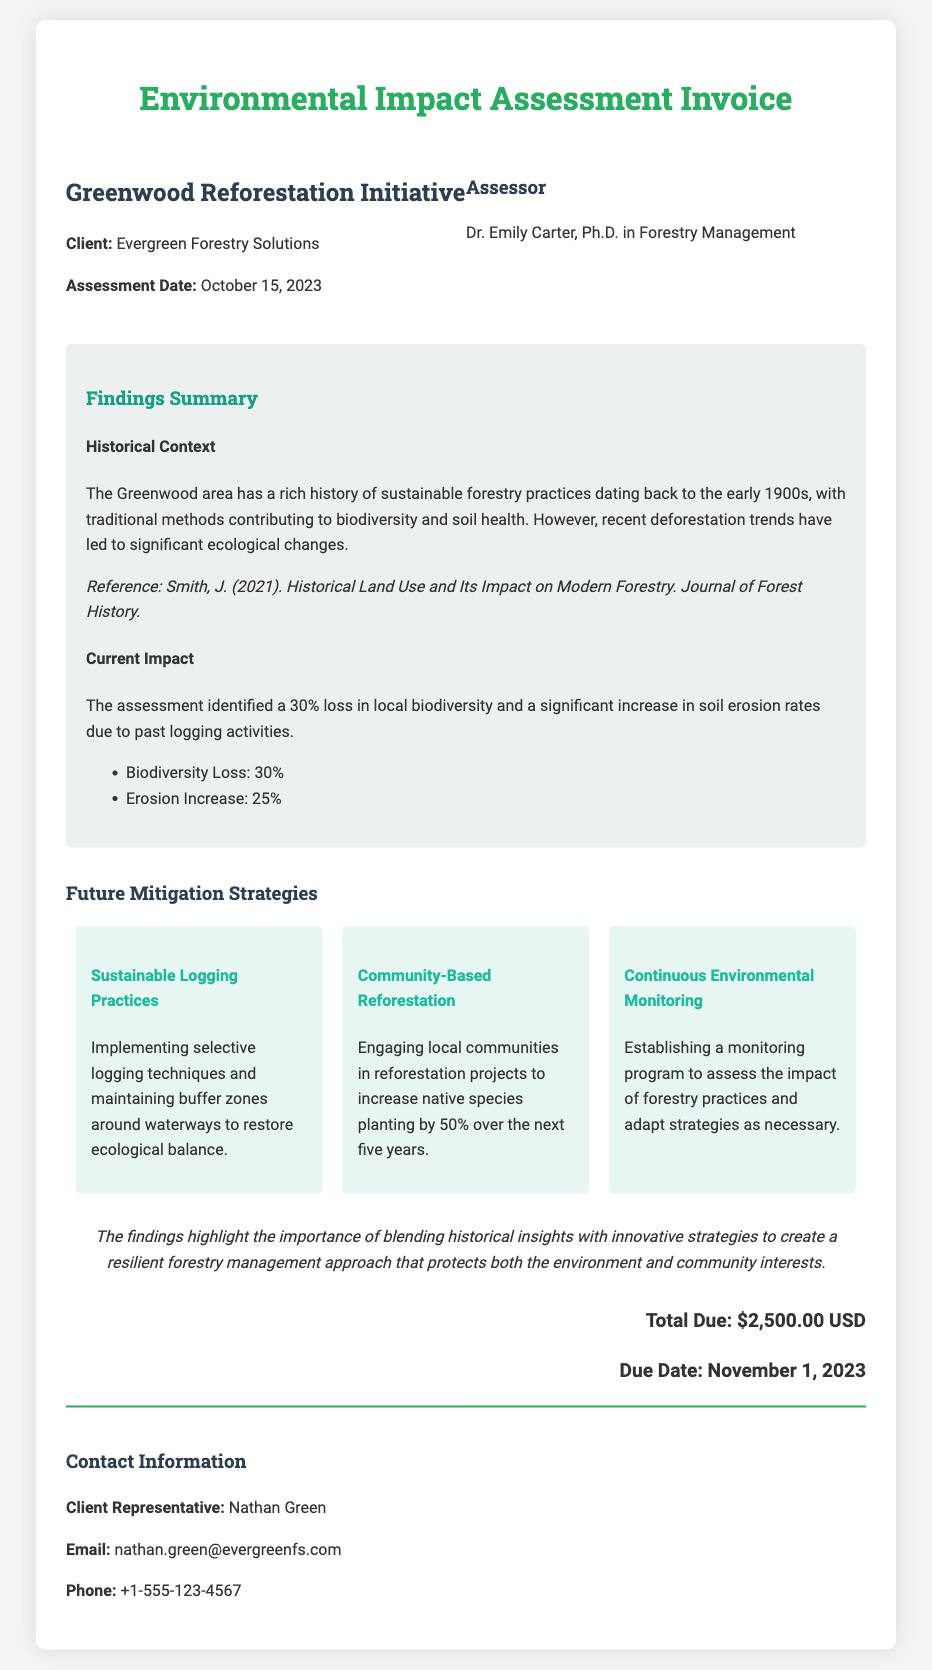What is the project title? The project title is stated at the beginning of the document.
Answer: Greenwood Reforestation Initiative Who is the client? The client is mentioned in the header section of the document.
Answer: Evergreen Forestry Solutions What is the assessment date? The assessment date can be found in the project information section.
Answer: October 15, 2023 What is the percentage loss in local biodiversity identified in the assessment? The document states the percentage loss of biodiversity under the findings section.
Answer: 30% What is the proposed increase in native species planting by local communities? The future mitigation strategies section highlights the target for native species planting.
Answer: 50% Who conducted the assessment? The assessor's name is provided in the header section of the document.
Answer: Dr. Emily Carter What is the total due for the assessment? The total amount due is specified near the end of the document.
Answer: $2,500.00 USD What are the two main historical impacts mentioned? The historical context lists two specific impacts relating to forestry practices.
Answer: Sustainable practices and significant ecological changes What mitigation strategy involves local communities? The future mitigation strategies emphasize the role of local communities in one specific strategy.
Answer: Community-Based Reforestation What is the due date for the payment? The due date is indicated in the financial summary at the end of the document.
Answer: November 1, 2023 